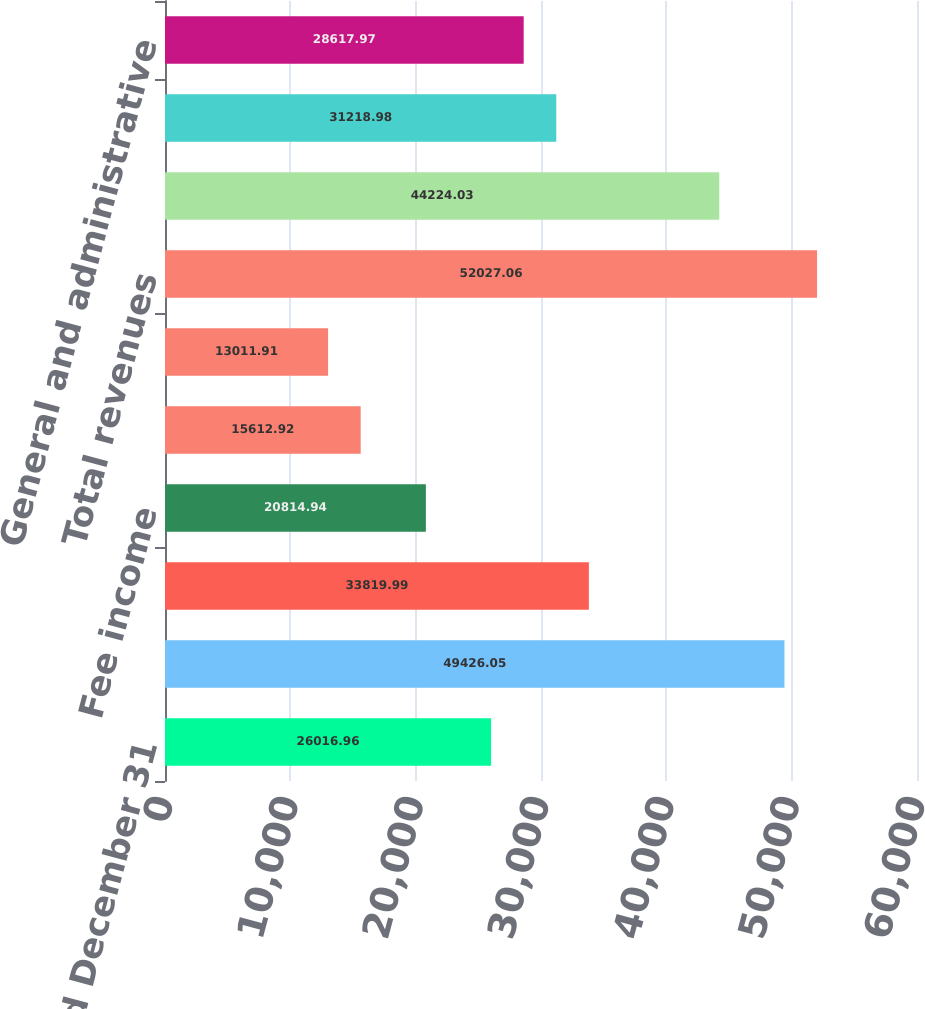<chart> <loc_0><loc_0><loc_500><loc_500><bar_chart><fcel>For the year ended December 31<fcel>Premiums<fcel>Net investment income<fcel>Fee income<fcel>Net realized investment gains<fcel>Other revenues<fcel>Total revenues<fcel>Claims and claim adjustment<fcel>Amortization of deferred<fcel>General and administrative<nl><fcel>26017<fcel>49426.1<fcel>33820<fcel>20814.9<fcel>15612.9<fcel>13011.9<fcel>52027.1<fcel>44224<fcel>31219<fcel>28618<nl></chart> 